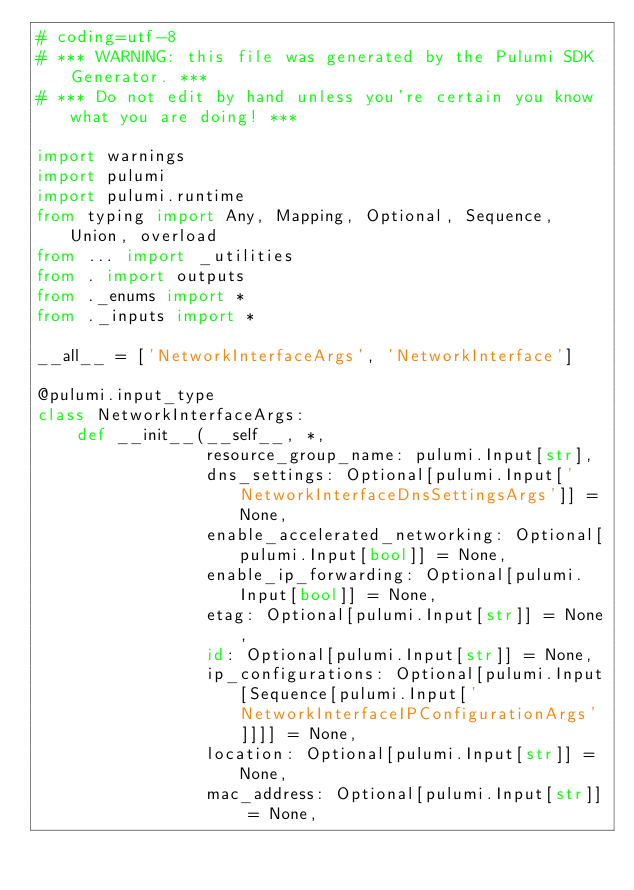<code> <loc_0><loc_0><loc_500><loc_500><_Python_># coding=utf-8
# *** WARNING: this file was generated by the Pulumi SDK Generator. ***
# *** Do not edit by hand unless you're certain you know what you are doing! ***

import warnings
import pulumi
import pulumi.runtime
from typing import Any, Mapping, Optional, Sequence, Union, overload
from ... import _utilities
from . import outputs
from ._enums import *
from ._inputs import *

__all__ = ['NetworkInterfaceArgs', 'NetworkInterface']

@pulumi.input_type
class NetworkInterfaceArgs:
    def __init__(__self__, *,
                 resource_group_name: pulumi.Input[str],
                 dns_settings: Optional[pulumi.Input['NetworkInterfaceDnsSettingsArgs']] = None,
                 enable_accelerated_networking: Optional[pulumi.Input[bool]] = None,
                 enable_ip_forwarding: Optional[pulumi.Input[bool]] = None,
                 etag: Optional[pulumi.Input[str]] = None,
                 id: Optional[pulumi.Input[str]] = None,
                 ip_configurations: Optional[pulumi.Input[Sequence[pulumi.Input['NetworkInterfaceIPConfigurationArgs']]]] = None,
                 location: Optional[pulumi.Input[str]] = None,
                 mac_address: Optional[pulumi.Input[str]] = None,</code> 